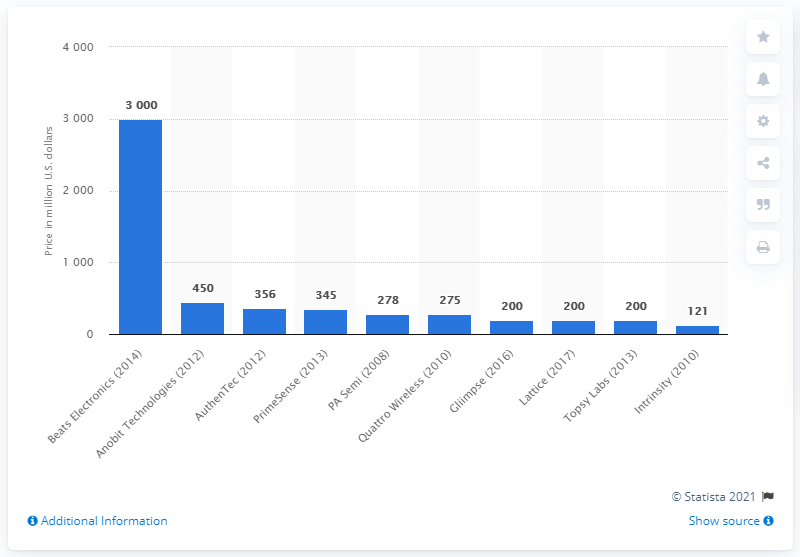Outline some significant characteristics in this image. On January 14th, 2014, Apple officially announced that they had acquired Beats Electronics for a whopping $3 billion. 